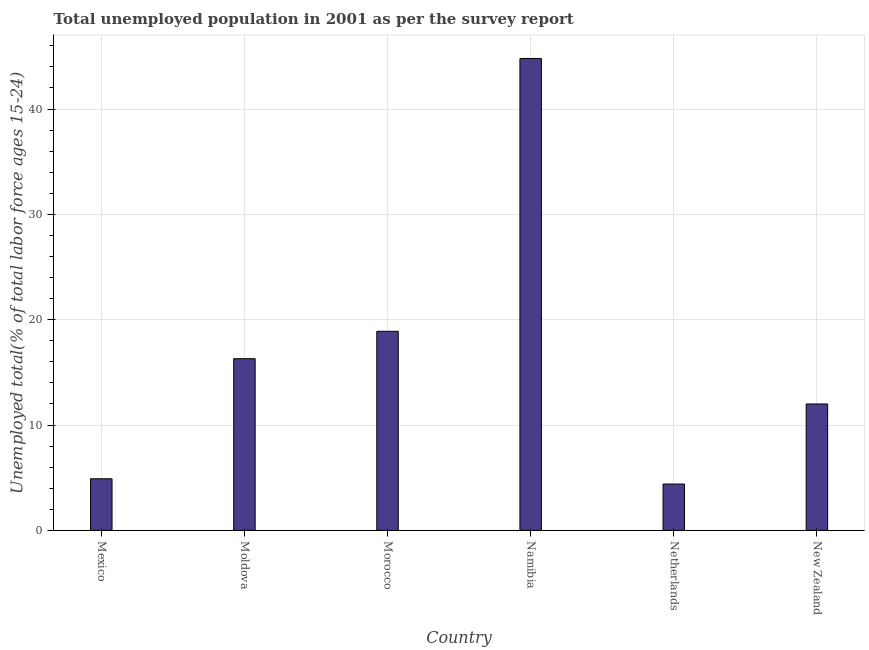Does the graph contain grids?
Keep it short and to the point. Yes. What is the title of the graph?
Keep it short and to the point. Total unemployed population in 2001 as per the survey report. What is the label or title of the Y-axis?
Your answer should be compact. Unemployed total(% of total labor force ages 15-24). What is the unemployed youth in Netherlands?
Your answer should be very brief. 4.4. Across all countries, what is the maximum unemployed youth?
Your response must be concise. 44.8. Across all countries, what is the minimum unemployed youth?
Give a very brief answer. 4.4. In which country was the unemployed youth maximum?
Offer a very short reply. Namibia. In which country was the unemployed youth minimum?
Your answer should be very brief. Netherlands. What is the sum of the unemployed youth?
Provide a short and direct response. 101.3. What is the difference between the unemployed youth in Mexico and New Zealand?
Offer a terse response. -7.1. What is the average unemployed youth per country?
Ensure brevity in your answer.  16.88. What is the median unemployed youth?
Ensure brevity in your answer.  14.15. In how many countries, is the unemployed youth greater than 34 %?
Keep it short and to the point. 1. What is the ratio of the unemployed youth in Namibia to that in New Zealand?
Your answer should be very brief. 3.73. Is the difference between the unemployed youth in Morocco and Netherlands greater than the difference between any two countries?
Offer a very short reply. No. What is the difference between the highest and the second highest unemployed youth?
Ensure brevity in your answer.  25.9. Is the sum of the unemployed youth in Mexico and Namibia greater than the maximum unemployed youth across all countries?
Offer a very short reply. Yes. What is the difference between the highest and the lowest unemployed youth?
Provide a succinct answer. 40.4. In how many countries, is the unemployed youth greater than the average unemployed youth taken over all countries?
Your answer should be compact. 2. How many bars are there?
Keep it short and to the point. 6. Are all the bars in the graph horizontal?
Your response must be concise. No. What is the difference between two consecutive major ticks on the Y-axis?
Give a very brief answer. 10. Are the values on the major ticks of Y-axis written in scientific E-notation?
Offer a very short reply. No. What is the Unemployed total(% of total labor force ages 15-24) in Mexico?
Your answer should be very brief. 4.9. What is the Unemployed total(% of total labor force ages 15-24) in Moldova?
Offer a terse response. 16.3. What is the Unemployed total(% of total labor force ages 15-24) of Morocco?
Offer a very short reply. 18.9. What is the Unemployed total(% of total labor force ages 15-24) in Namibia?
Ensure brevity in your answer.  44.8. What is the Unemployed total(% of total labor force ages 15-24) of Netherlands?
Provide a succinct answer. 4.4. What is the difference between the Unemployed total(% of total labor force ages 15-24) in Mexico and Moldova?
Your response must be concise. -11.4. What is the difference between the Unemployed total(% of total labor force ages 15-24) in Mexico and Namibia?
Keep it short and to the point. -39.9. What is the difference between the Unemployed total(% of total labor force ages 15-24) in Mexico and Netherlands?
Your response must be concise. 0.5. What is the difference between the Unemployed total(% of total labor force ages 15-24) in Mexico and New Zealand?
Provide a short and direct response. -7.1. What is the difference between the Unemployed total(% of total labor force ages 15-24) in Moldova and Morocco?
Make the answer very short. -2.6. What is the difference between the Unemployed total(% of total labor force ages 15-24) in Moldova and Namibia?
Your answer should be very brief. -28.5. What is the difference between the Unemployed total(% of total labor force ages 15-24) in Moldova and Netherlands?
Ensure brevity in your answer.  11.9. What is the difference between the Unemployed total(% of total labor force ages 15-24) in Morocco and Namibia?
Offer a very short reply. -25.9. What is the difference between the Unemployed total(% of total labor force ages 15-24) in Morocco and Netherlands?
Ensure brevity in your answer.  14.5. What is the difference between the Unemployed total(% of total labor force ages 15-24) in Morocco and New Zealand?
Ensure brevity in your answer.  6.9. What is the difference between the Unemployed total(% of total labor force ages 15-24) in Namibia and Netherlands?
Your response must be concise. 40.4. What is the difference between the Unemployed total(% of total labor force ages 15-24) in Namibia and New Zealand?
Provide a succinct answer. 32.8. What is the difference between the Unemployed total(% of total labor force ages 15-24) in Netherlands and New Zealand?
Offer a terse response. -7.6. What is the ratio of the Unemployed total(% of total labor force ages 15-24) in Mexico to that in Moldova?
Your response must be concise. 0.3. What is the ratio of the Unemployed total(% of total labor force ages 15-24) in Mexico to that in Morocco?
Give a very brief answer. 0.26. What is the ratio of the Unemployed total(% of total labor force ages 15-24) in Mexico to that in Namibia?
Offer a very short reply. 0.11. What is the ratio of the Unemployed total(% of total labor force ages 15-24) in Mexico to that in Netherlands?
Give a very brief answer. 1.11. What is the ratio of the Unemployed total(% of total labor force ages 15-24) in Mexico to that in New Zealand?
Offer a terse response. 0.41. What is the ratio of the Unemployed total(% of total labor force ages 15-24) in Moldova to that in Morocco?
Offer a very short reply. 0.86. What is the ratio of the Unemployed total(% of total labor force ages 15-24) in Moldova to that in Namibia?
Your response must be concise. 0.36. What is the ratio of the Unemployed total(% of total labor force ages 15-24) in Moldova to that in Netherlands?
Keep it short and to the point. 3.71. What is the ratio of the Unemployed total(% of total labor force ages 15-24) in Moldova to that in New Zealand?
Provide a succinct answer. 1.36. What is the ratio of the Unemployed total(% of total labor force ages 15-24) in Morocco to that in Namibia?
Offer a very short reply. 0.42. What is the ratio of the Unemployed total(% of total labor force ages 15-24) in Morocco to that in Netherlands?
Your answer should be compact. 4.29. What is the ratio of the Unemployed total(% of total labor force ages 15-24) in Morocco to that in New Zealand?
Provide a succinct answer. 1.57. What is the ratio of the Unemployed total(% of total labor force ages 15-24) in Namibia to that in Netherlands?
Provide a short and direct response. 10.18. What is the ratio of the Unemployed total(% of total labor force ages 15-24) in Namibia to that in New Zealand?
Provide a succinct answer. 3.73. What is the ratio of the Unemployed total(% of total labor force ages 15-24) in Netherlands to that in New Zealand?
Provide a succinct answer. 0.37. 